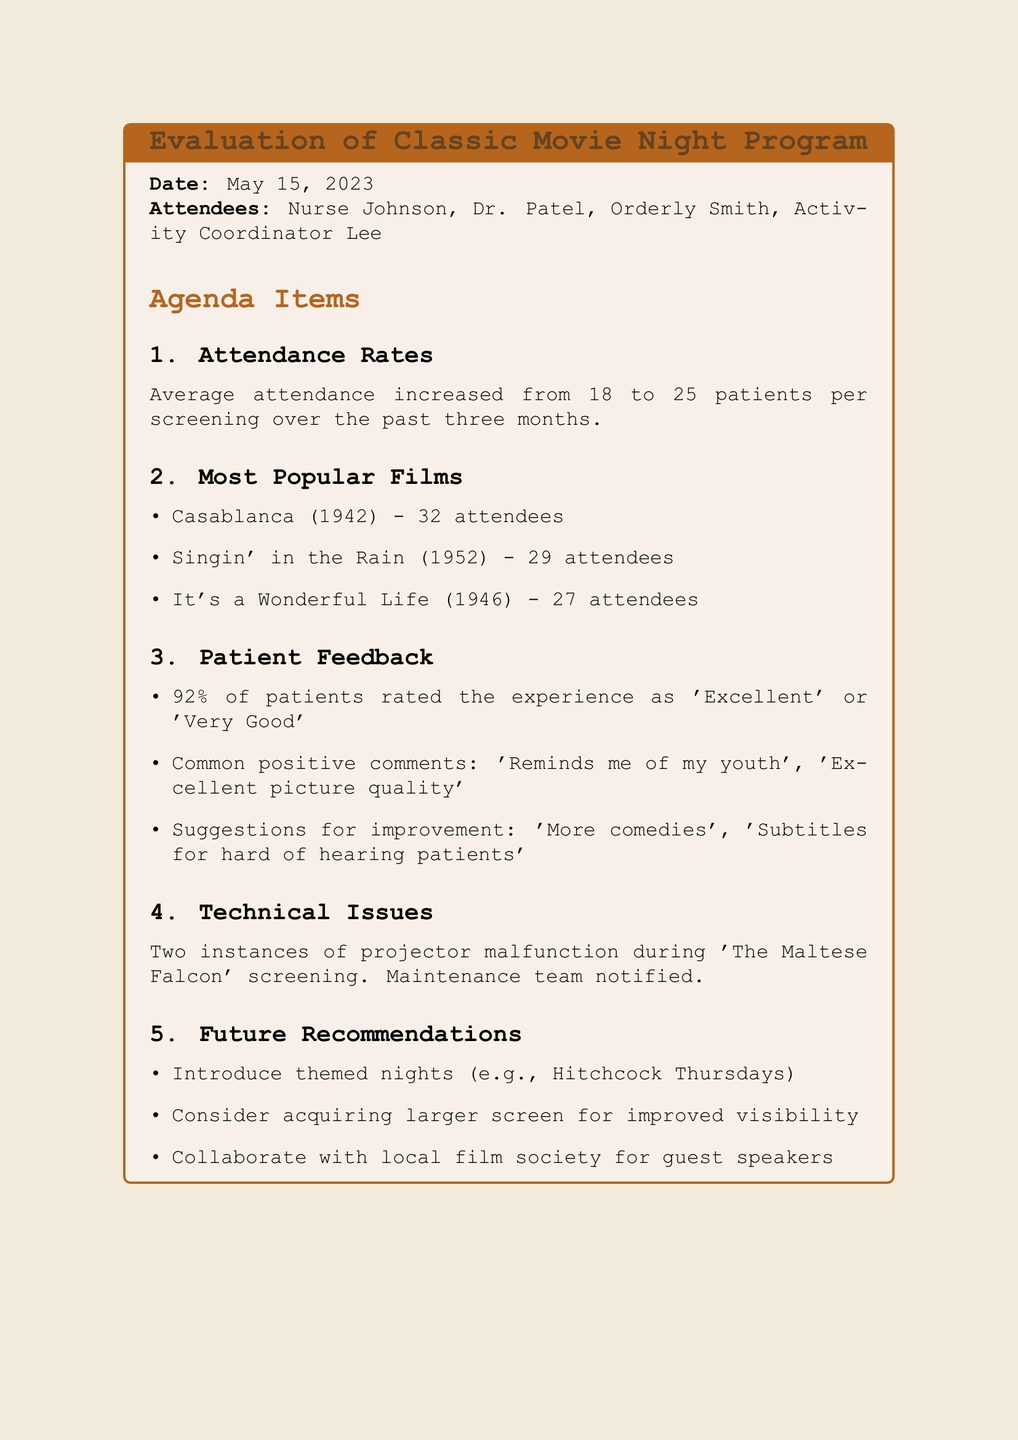What was the date of the meeting? The date of the meeting is mentioned at the beginning of the document.
Answer: May 15, 2023 How many patients attended the screening of Casablanca? The attendance for Casablanca is listed under the most popular films section.
Answer: 32 attendees What percentage of patients rated the experience positively? The percentage is provided under the Patient Feedback section.
Answer: 92% What were the two suggestions for improvement mentioned? The suggestions are outlined in the Patient Feedback section and include specific recommendations.
Answer: More comedies, Subtitles for hard of hearing patients What is one of the future recommendations discussed? Future recommendations are listed and specify plans moving forward.
Answer: Introduce themed nights (e.g., Hitchcock Thursdays) What technical issues occurred during which film? The technical issues involving the projector are detailed in the relevant section.
Answer: The Maltese Falcon What was the average attendance increase per screening? The average attendance is stated in the Attendance Rates section, indicating the change over the past three months.
Answer: from 18 to 25 patients Who were the attendees of the meeting? The attendees are listed early in the document, giving a clear picture of who participated.
Answer: Nurse Johnson, Dr. Patel, Orderly Smith, Activity Coordinator Lee 